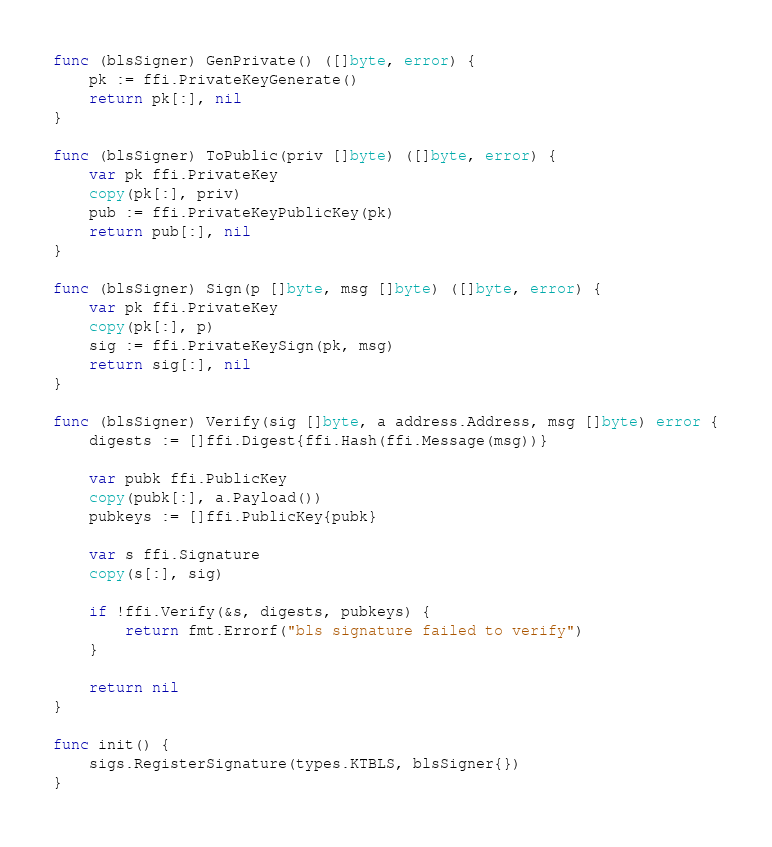Convert code to text. <code><loc_0><loc_0><loc_500><loc_500><_Go_>func (blsSigner) GenPrivate() ([]byte, error) {
	pk := ffi.PrivateKeyGenerate()
	return pk[:], nil
}

func (blsSigner) ToPublic(priv []byte) ([]byte, error) {
	var pk ffi.PrivateKey
	copy(pk[:], priv)
	pub := ffi.PrivateKeyPublicKey(pk)
	return pub[:], nil
}

func (blsSigner) Sign(p []byte, msg []byte) ([]byte, error) {
	var pk ffi.PrivateKey
	copy(pk[:], p)
	sig := ffi.PrivateKeySign(pk, msg)
	return sig[:], nil
}

func (blsSigner) Verify(sig []byte, a address.Address, msg []byte) error {
	digests := []ffi.Digest{ffi.Hash(ffi.Message(msg))}

	var pubk ffi.PublicKey
	copy(pubk[:], a.Payload())
	pubkeys := []ffi.PublicKey{pubk}

	var s ffi.Signature
	copy(s[:], sig)

	if !ffi.Verify(&s, digests, pubkeys) {
		return fmt.Errorf("bls signature failed to verify")
	}

	return nil
}

func init() {
	sigs.RegisterSignature(types.KTBLS, blsSigner{})
}
</code> 